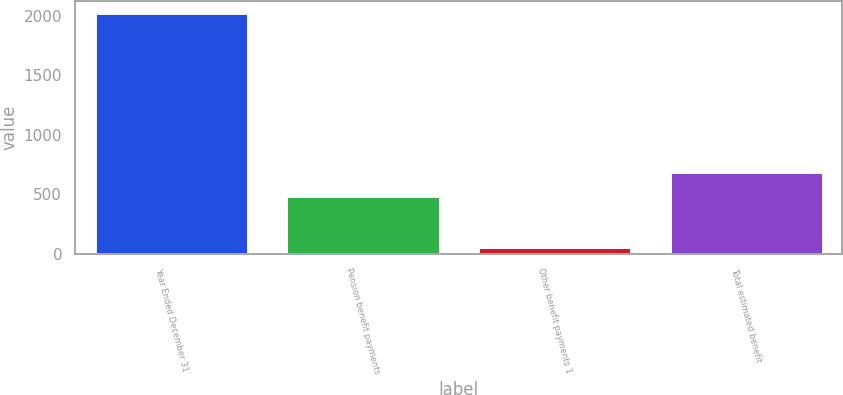Convert chart. <chart><loc_0><loc_0><loc_500><loc_500><bar_chart><fcel>Year Ended December 31<fcel>Pension benefit payments<fcel>Other benefit payments 1<fcel>Total estimated benefit<nl><fcel>2021<fcel>489<fcel>59<fcel>685.2<nl></chart> 